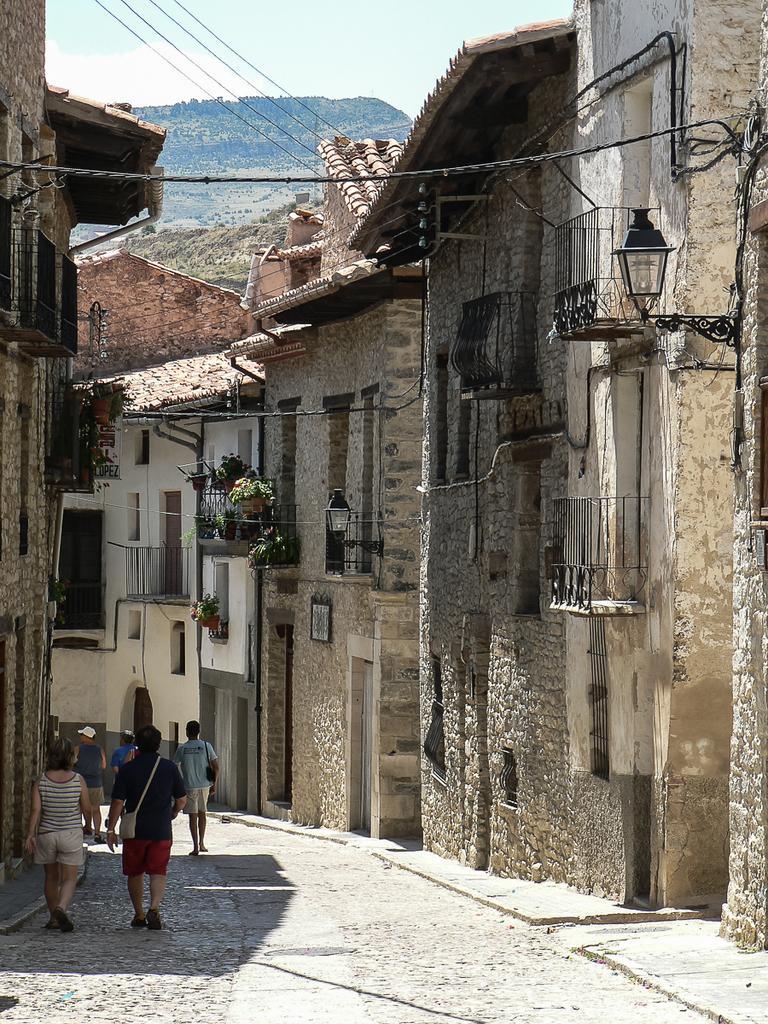Describe this image in one or two sentences. In the image I can see the view of a place where we have some buildings, plants and also I can see some people on the road. 